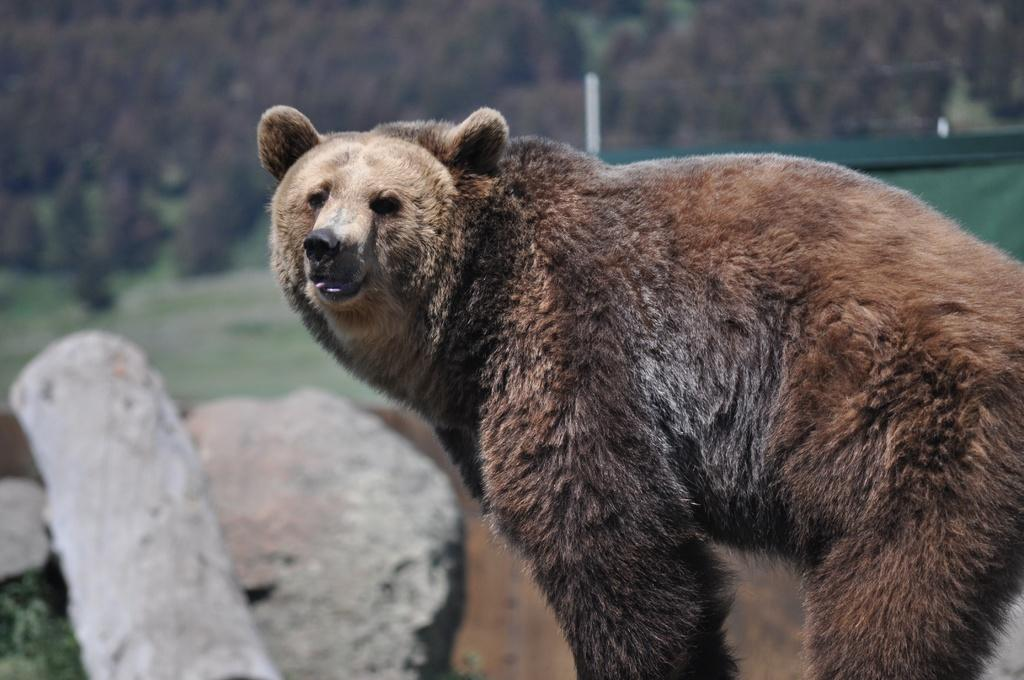What type of animal is in the image? There is a brown color bear in the image. How would you describe the background of the image? The background of the image is slightly blurred. What type of natural elements can be seen in the background? Rocks, grass, and trees are present in the background of the image. What is the queen doing in the image? There is no queen present in the image; it features a brown color bear and a natural background. 